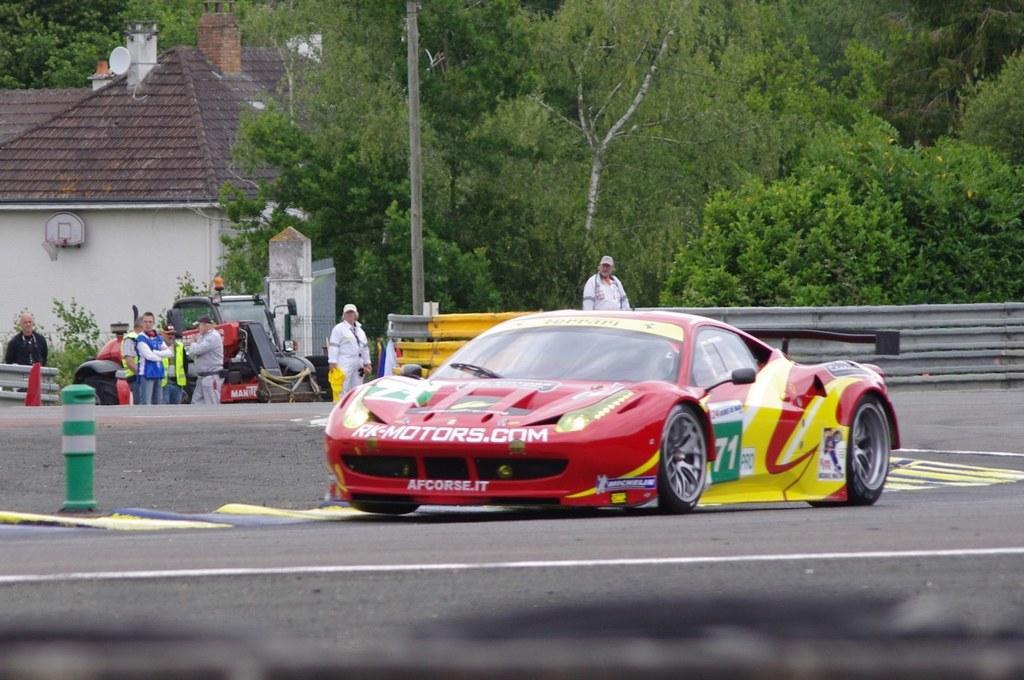In one or two sentences, can you explain what this image depicts? In this image we can see a car and a pole placed on the road. On the backside we can see a vehicle, fence, pole and a group of people standing. We can also see a group of trees. 